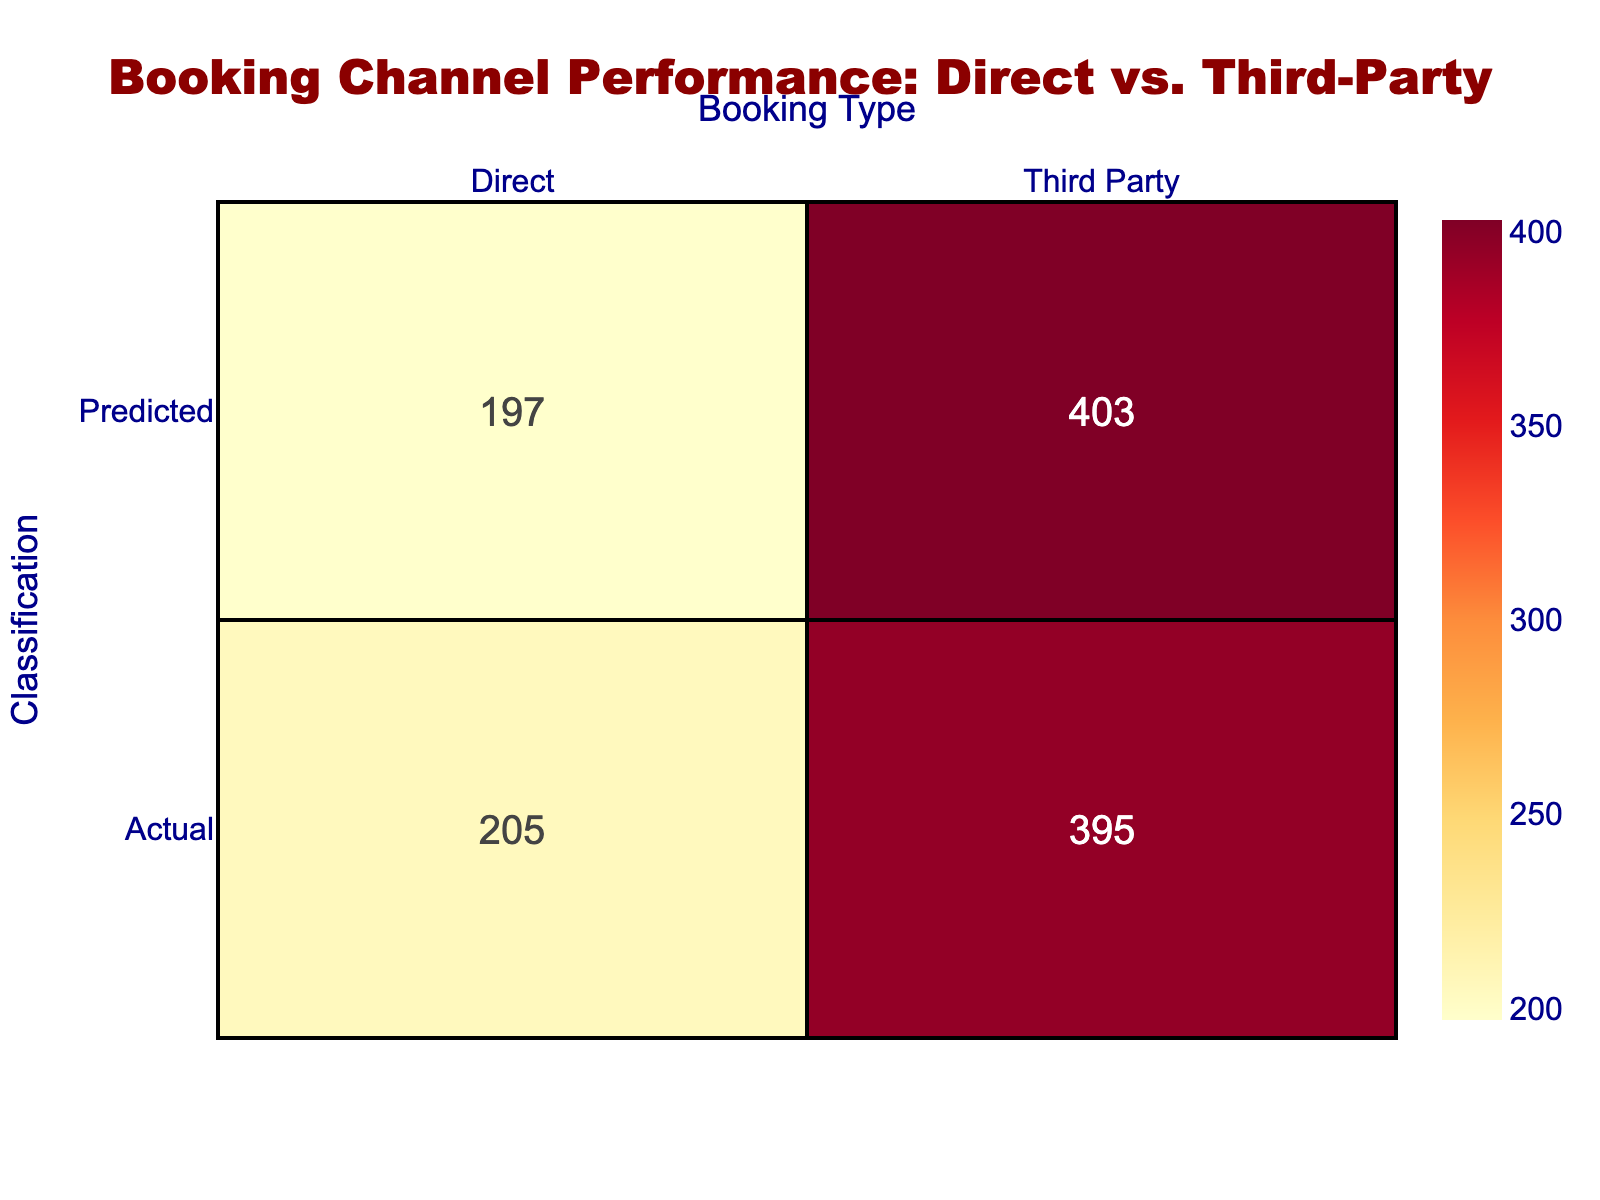What is the actual number of direct bookings for Booking.com? By looking at the row for Booking.com in the table, we can see that the value under Actual_Direct is 80.
Answer: 80 What is the predicted number of third-party bookings for Airbnb? Looking at the Airbnb row, the value under Predict_Third_Party is 98.
Answer: 98 How many total actual bookings were there for all channels combined? To find the total actual bookings, we add Actual_Direct and Actual_Third_Party for all channels: (80 + 20) + (15 + 85) + (10 + 90) + (65 + 35) + (30 + 70) + (5 + 95) =  80 + 20 + 15 + 85 + 10 + 90 + 65 + 35 + 30 + 70 + 5 + 95 =  605.
Answer: 605 Did the hotel's website have more actual direct bookings than Expedia? The actual direct bookings for the hotel's website are 65, while for Expedia they are 15. Since 65 is greater than 15, the statement is true.
Answer: Yes What is the difference between the total predicted direct bookings and the total actual direct bookings? First, we find the total predicted direct bookings by adding the Predict_Direct column: 75 + 10 + 5 + 70 + 35 + 2 = 197. Next, the total actual direct bookings is 605 (as calculated earlier). Now, we find the difference: 605 - 197 = 408.
Answer: 408 Are there more actual third-party bookings than predicted third-party bookings across all channels combined? The total actual third-party bookings sum to 600 (calculated by adding Actual_Third_Party), and the predicted third-party bookings sum to 575. Since 600 > 575, the answer is yes.
Answer: Yes Which channel has the highest predicted direct bookings? The row with the highest value in the Predict_Direct column is Booking.com, which has a value of 75.
Answer: Booking.com What percentage of the actual bookings for Trip.com were third-party? To find this percentage, we calculate the actual third-party bookings for Trip.com (70) and the total actual bookings for Trip.com (30 + 70 = 100). The percentage is (70/100) * 100 = 70%.
Answer: 70% What is the total predicted third-party bookings for all channels? We add up the values in the Predict_Third_Party column: 25 + 90 + 95 + 30 + 65 + 98 = 403.
Answer: 403 